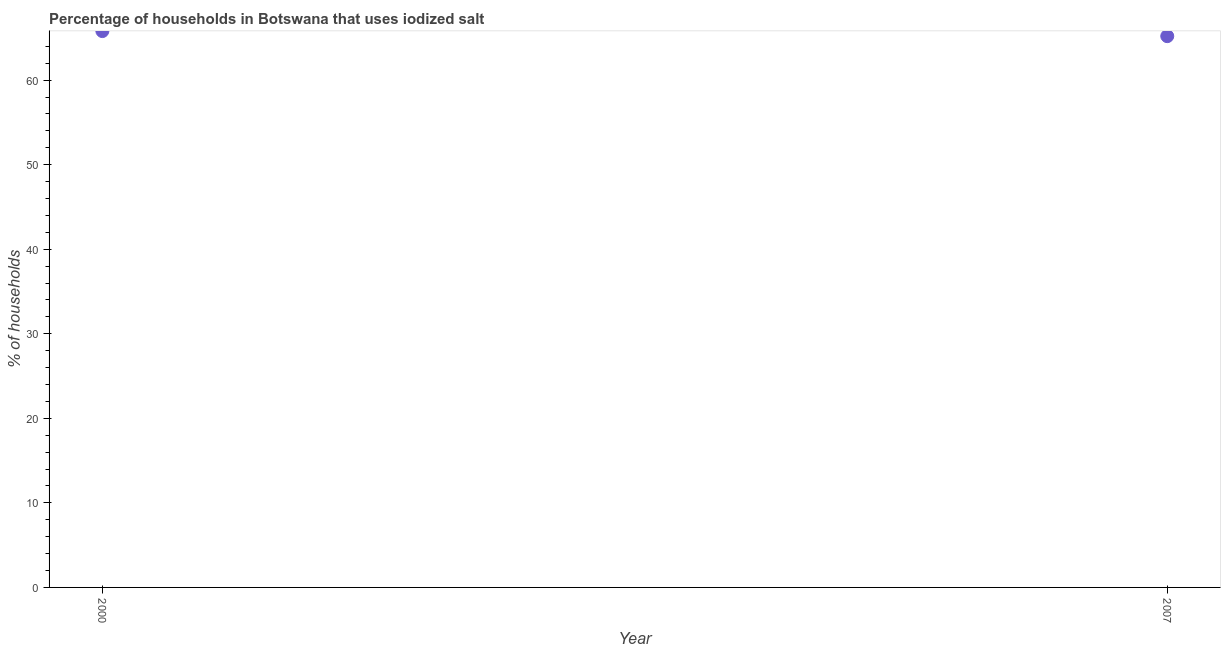What is the percentage of households where iodized salt is consumed in 2000?
Provide a succinct answer. 65.8. Across all years, what is the maximum percentage of households where iodized salt is consumed?
Ensure brevity in your answer.  65.8. Across all years, what is the minimum percentage of households where iodized salt is consumed?
Your response must be concise. 65.2. In which year was the percentage of households where iodized salt is consumed minimum?
Your response must be concise. 2007. What is the sum of the percentage of households where iodized salt is consumed?
Provide a short and direct response. 131. What is the difference between the percentage of households where iodized salt is consumed in 2000 and 2007?
Provide a short and direct response. 0.6. What is the average percentage of households where iodized salt is consumed per year?
Your answer should be very brief. 65.5. What is the median percentage of households where iodized salt is consumed?
Make the answer very short. 65.5. In how many years, is the percentage of households where iodized salt is consumed greater than 14 %?
Provide a short and direct response. 2. What is the ratio of the percentage of households where iodized salt is consumed in 2000 to that in 2007?
Your answer should be very brief. 1.01. How many dotlines are there?
Give a very brief answer. 1. How many years are there in the graph?
Your answer should be compact. 2. Does the graph contain grids?
Make the answer very short. No. What is the title of the graph?
Offer a very short reply. Percentage of households in Botswana that uses iodized salt. What is the label or title of the X-axis?
Provide a succinct answer. Year. What is the label or title of the Y-axis?
Your answer should be compact. % of households. What is the % of households in 2000?
Provide a succinct answer. 65.8. What is the % of households in 2007?
Provide a succinct answer. 65.2. What is the difference between the % of households in 2000 and 2007?
Give a very brief answer. 0.6. What is the ratio of the % of households in 2000 to that in 2007?
Provide a succinct answer. 1.01. 